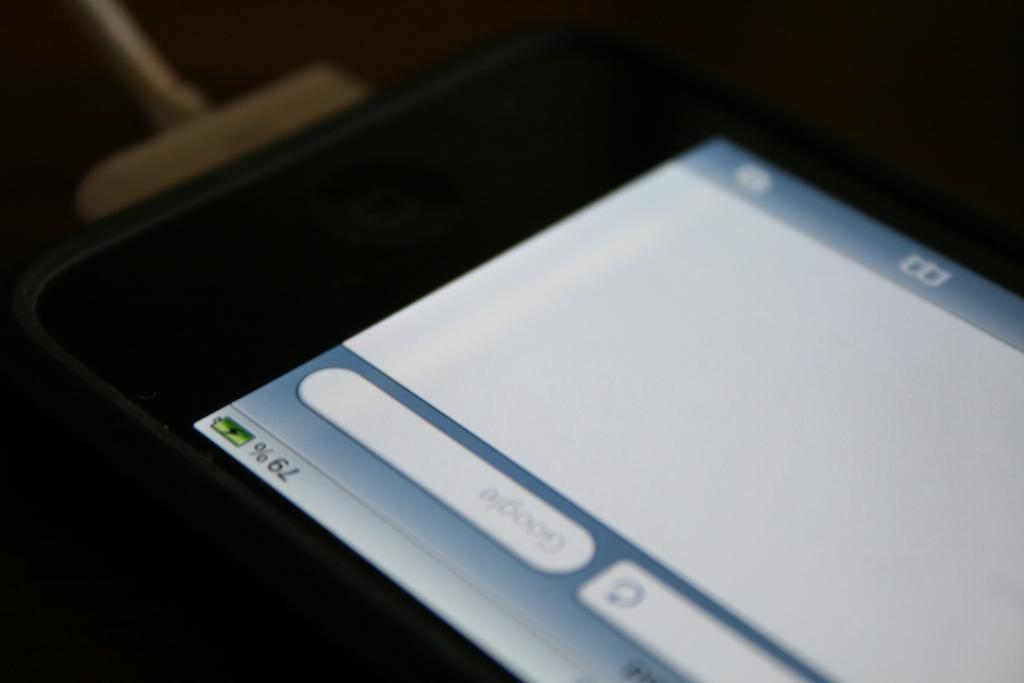<image>
Summarize the visual content of the image. A black iPhone is charging and at 79 percent battery. 